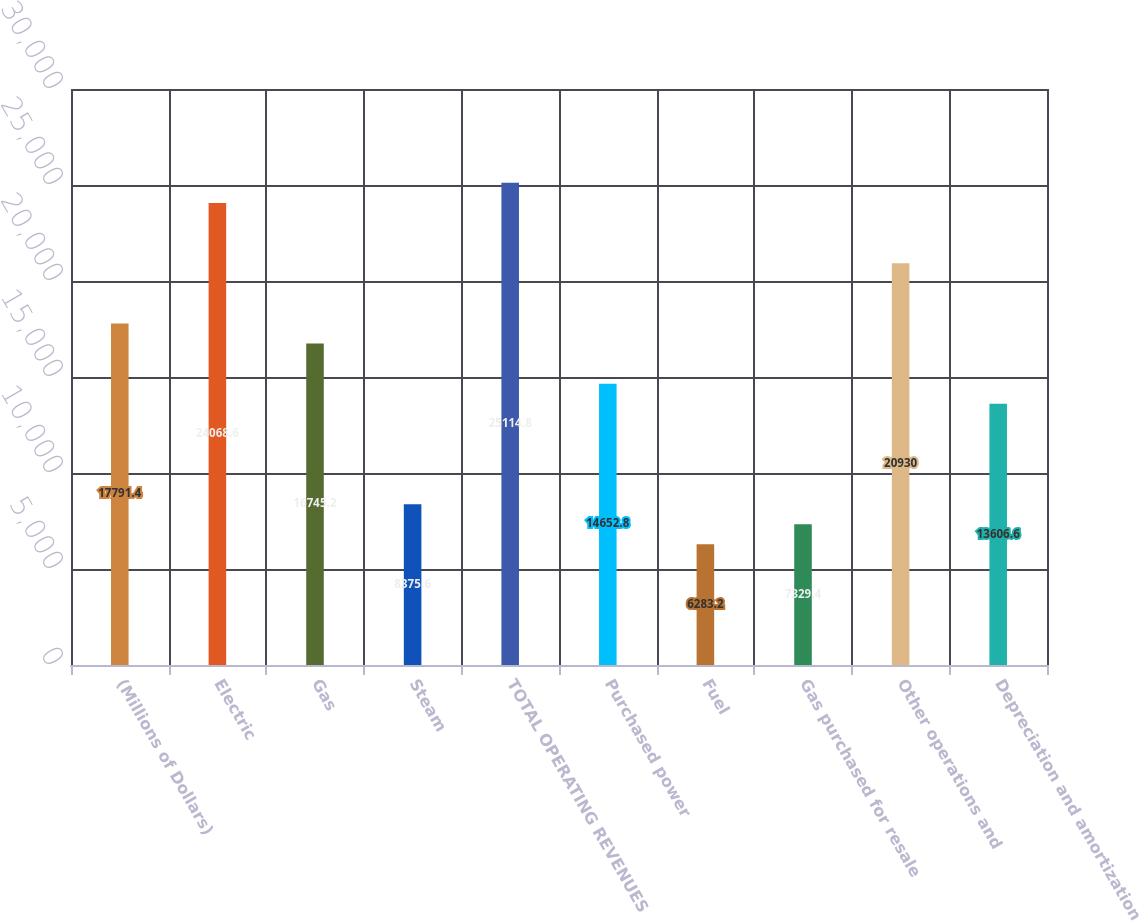<chart> <loc_0><loc_0><loc_500><loc_500><bar_chart><fcel>(Millions of Dollars)<fcel>Electric<fcel>Gas<fcel>Steam<fcel>TOTAL OPERATING REVENUES<fcel>Purchased power<fcel>Fuel<fcel>Gas purchased for resale<fcel>Other operations and<fcel>Depreciation and amortization<nl><fcel>17791.4<fcel>24068.6<fcel>16745.2<fcel>8375.6<fcel>25114.8<fcel>14652.8<fcel>6283.2<fcel>7329.4<fcel>20930<fcel>13606.6<nl></chart> 